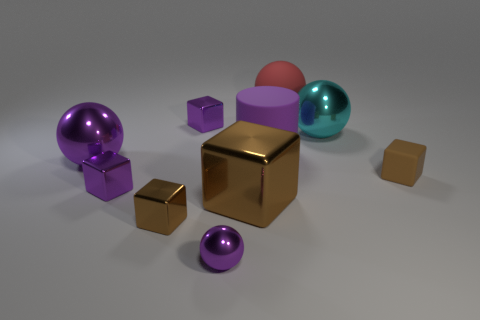Subtract all cyan spheres. How many spheres are left? 3 Subtract all brown cubes. How many cubes are left? 2 Subtract all cylinders. How many objects are left? 9 Subtract 0 brown cylinders. How many objects are left? 10 Subtract 5 cubes. How many cubes are left? 0 Subtract all gray blocks. Subtract all red balls. How many blocks are left? 5 Subtract all purple balls. How many green cubes are left? 0 Subtract all tiny matte objects. Subtract all small brown objects. How many objects are left? 7 Add 4 brown rubber cubes. How many brown rubber cubes are left? 5 Add 2 big blocks. How many big blocks exist? 3 